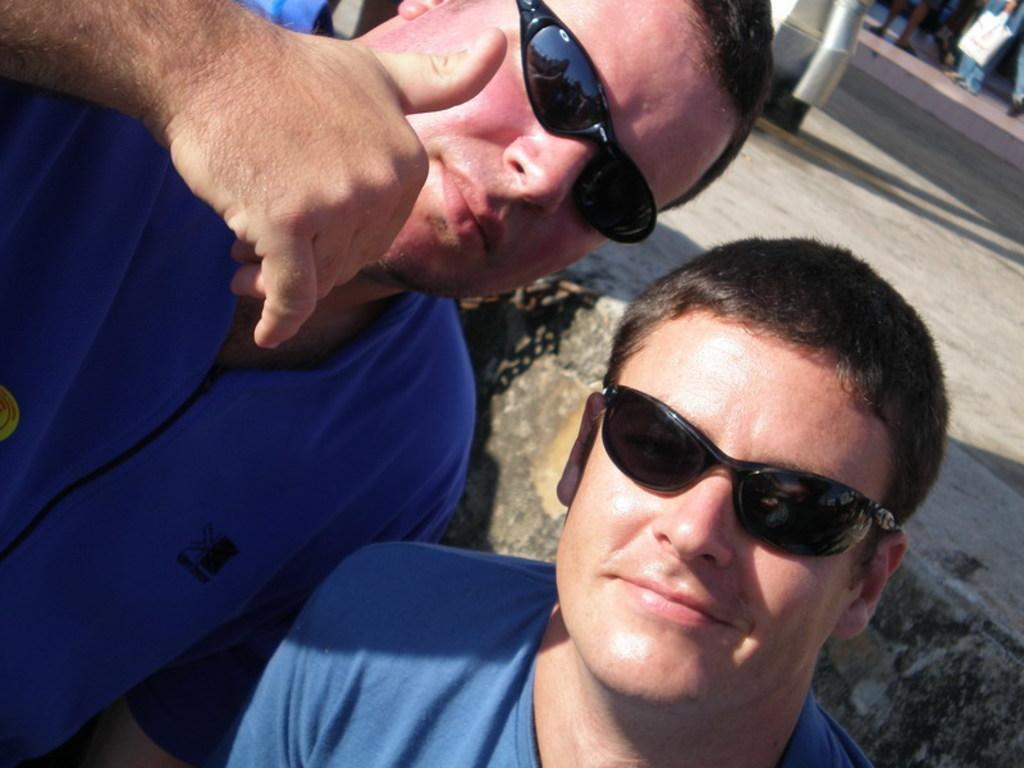How many men are in the image? There are two men in the image. What are the men wearing in the image? Both men are wearing blue dresses and black shades. Are there any other people present in the image? Yes, there are people standing in the image. What type of theory is the man on the left discussing with the man on the right? There is no indication in the image that the men are discussing any theory. Can you tell me what drug the man on the right is holding in the image? There is no drug present in the image; both men are wearing black shades and blue dresses. 